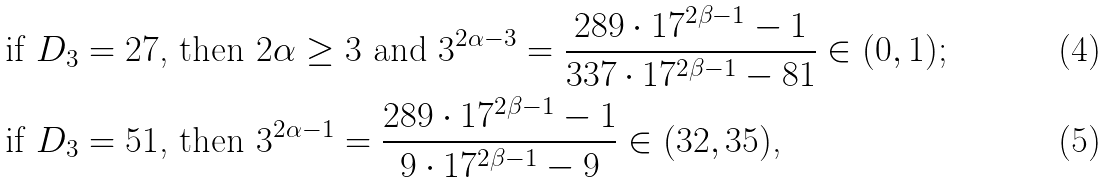Convert formula to latex. <formula><loc_0><loc_0><loc_500><loc_500>& \text {if $D_{3}=27$, then $2\alpha \geq3$ and $3^{2\alpha-3}= \frac{289\cdot17^{2\beta-1}-1}{337\cdot17^{2\beta-1}-81} \in (0,1)$;} \\ & \text {if $D_{3}=51$, then $3^{2\alpha-1}= \frac{289\cdot 17^{2\beta-1}-1}{9\cdot17^{2\beta-1}-9}\in (32,35)$,}</formula> 